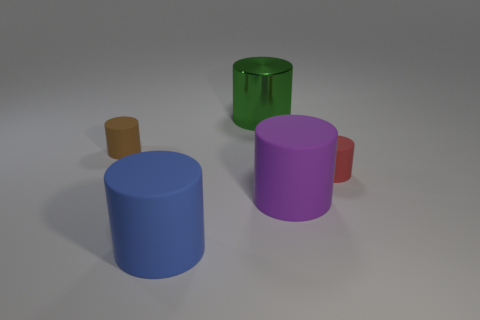There is a big blue object; are there any big blue cylinders behind it?
Provide a short and direct response. No. How many things are on the left side of the small rubber object on the right side of the blue thing?
Your answer should be compact. 4. The purple thing that is the same material as the blue cylinder is what size?
Keep it short and to the point. Large. What size is the green shiny object?
Give a very brief answer. Large. Are the small red cylinder and the small brown cylinder made of the same material?
Your response must be concise. Yes. How many blocks are either tiny red metal things or brown objects?
Offer a terse response. 0. What color is the object behind the tiny matte cylinder that is left of the big blue rubber cylinder?
Give a very brief answer. Green. How many purple matte cylinders are behind the big rubber object that is on the left side of the large thing that is behind the large purple rubber cylinder?
Your answer should be compact. 1. There is a big thing to the left of the big metal thing; is it the same shape as the rubber thing that is behind the red thing?
Your answer should be very brief. Yes. How many things are big cylinders or small rubber objects?
Provide a short and direct response. 5. 